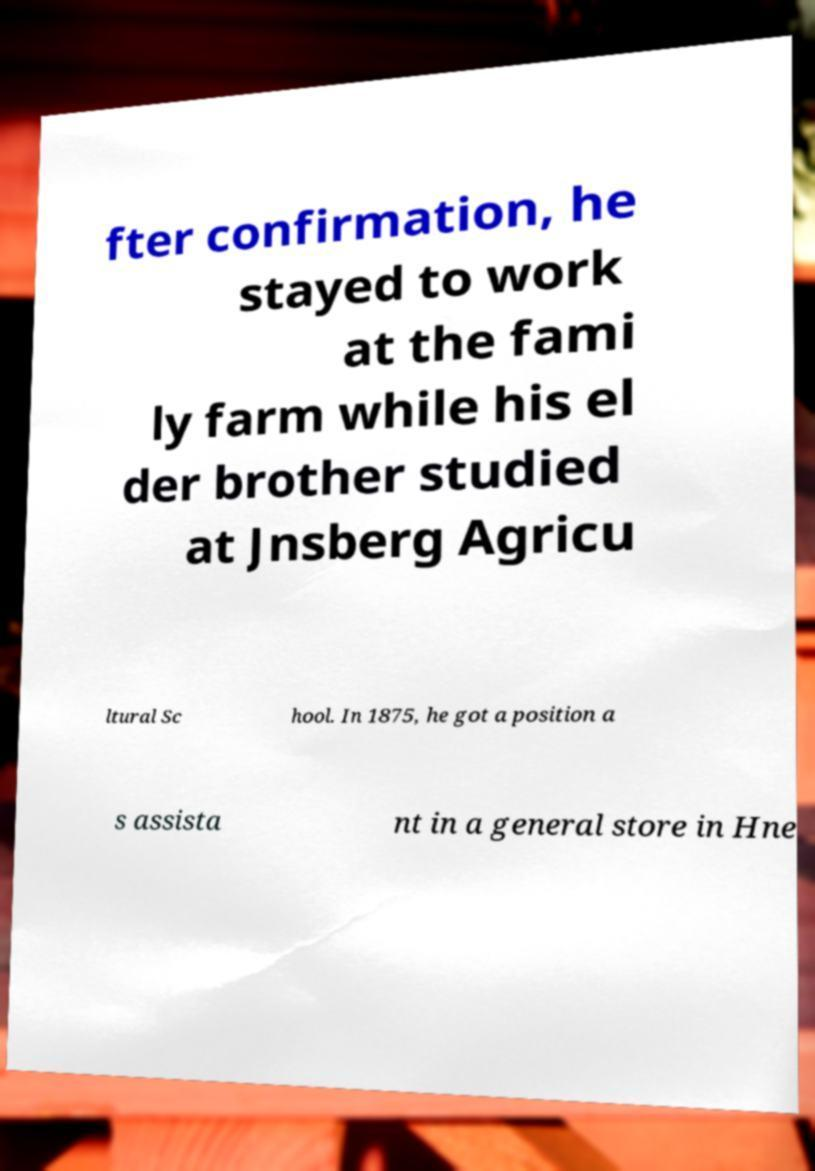I need the written content from this picture converted into text. Can you do that? fter confirmation, he stayed to work at the fami ly farm while his el der brother studied at Jnsberg Agricu ltural Sc hool. In 1875, he got a position a s assista nt in a general store in Hne 